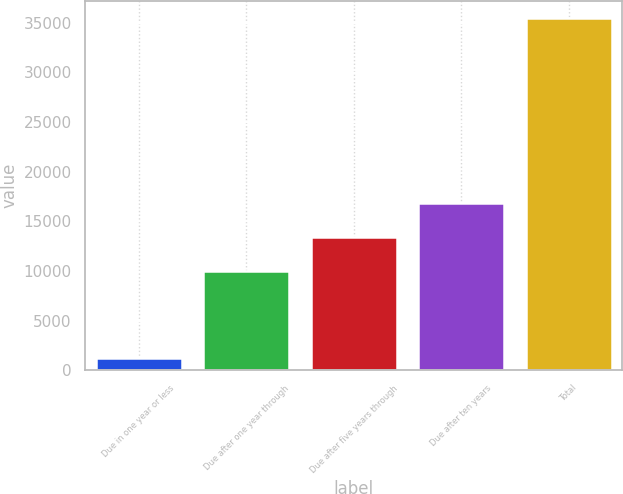<chart> <loc_0><loc_0><loc_500><loc_500><bar_chart><fcel>Due in one year or less<fcel>Due after one year through<fcel>Due after five years through<fcel>Due after ten years<fcel>Total<nl><fcel>1240<fcel>10046<fcel>13464.9<fcel>16883.8<fcel>35429<nl></chart> 